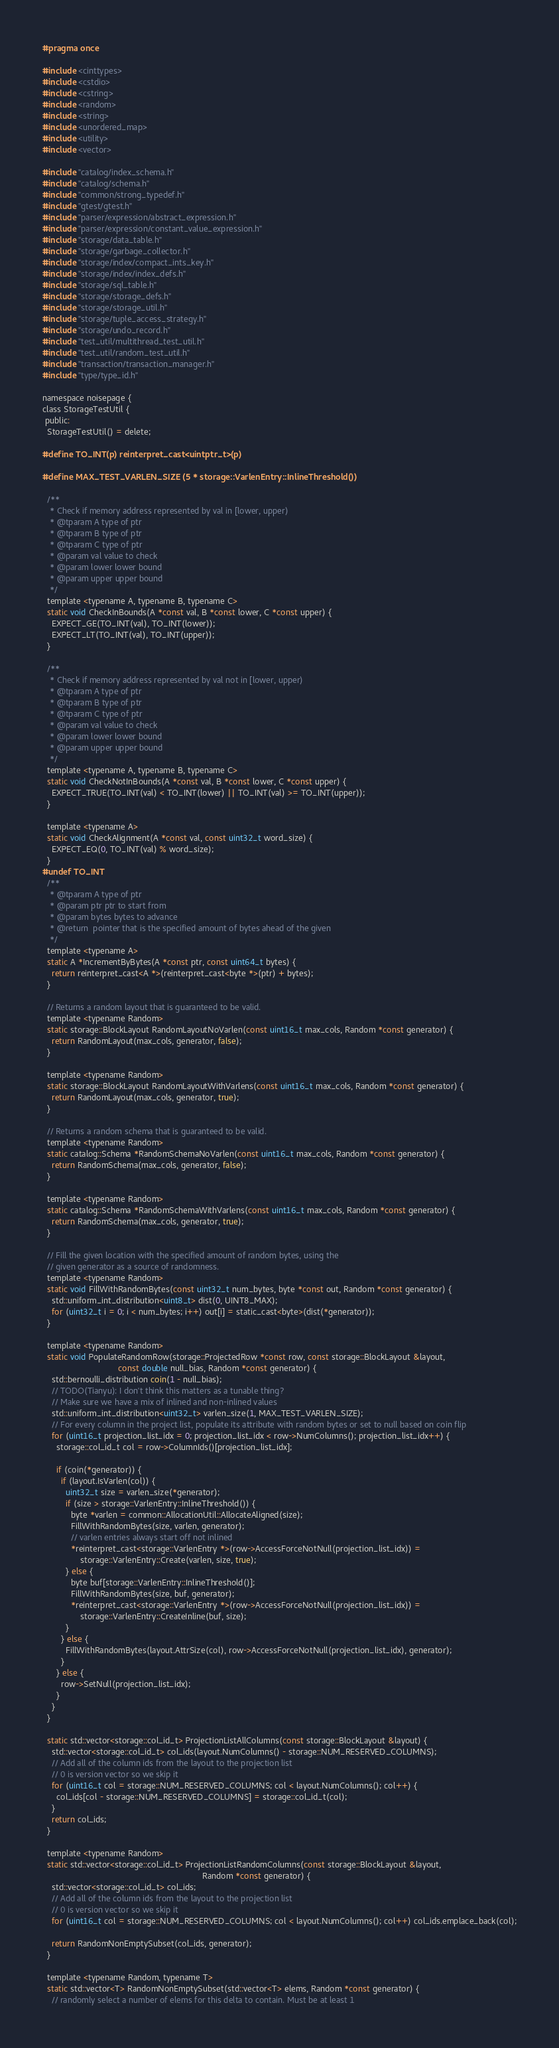<code> <loc_0><loc_0><loc_500><loc_500><_C_>#pragma once

#include <cinttypes>
#include <cstdio>
#include <cstring>
#include <random>
#include <string>
#include <unordered_map>
#include <utility>
#include <vector>

#include "catalog/index_schema.h"
#include "catalog/schema.h"
#include "common/strong_typedef.h"
#include "gtest/gtest.h"
#include "parser/expression/abstract_expression.h"
#include "parser/expression/constant_value_expression.h"
#include "storage/data_table.h"
#include "storage/garbage_collector.h"
#include "storage/index/compact_ints_key.h"
#include "storage/index/index_defs.h"
#include "storage/sql_table.h"
#include "storage/storage_defs.h"
#include "storage/storage_util.h"
#include "storage/tuple_access_strategy.h"
#include "storage/undo_record.h"
#include "test_util/multithread_test_util.h"
#include "test_util/random_test_util.h"
#include "transaction/transaction_manager.h"
#include "type/type_id.h"

namespace noisepage {
class StorageTestUtil {
 public:
  StorageTestUtil() = delete;

#define TO_INT(p) reinterpret_cast<uintptr_t>(p)

#define MAX_TEST_VARLEN_SIZE (5 * storage::VarlenEntry::InlineThreshold())

  /**
   * Check if memory address represented by val in [lower, upper)
   * @tparam A type of ptr
   * @tparam B type of ptr
   * @tparam C type of ptr
   * @param val value to check
   * @param lower lower bound
   * @param upper upper bound
   */
  template <typename A, typename B, typename C>
  static void CheckInBounds(A *const val, B *const lower, C *const upper) {
    EXPECT_GE(TO_INT(val), TO_INT(lower));
    EXPECT_LT(TO_INT(val), TO_INT(upper));
  }

  /**
   * Check if memory address represented by val not in [lower, upper)
   * @tparam A type of ptr
   * @tparam B type of ptr
   * @tparam C type of ptr
   * @param val value to check
   * @param lower lower bound
   * @param upper upper bound
   */
  template <typename A, typename B, typename C>
  static void CheckNotInBounds(A *const val, B *const lower, C *const upper) {
    EXPECT_TRUE(TO_INT(val) < TO_INT(lower) || TO_INT(val) >= TO_INT(upper));
  }

  template <typename A>
  static void CheckAlignment(A *const val, const uint32_t word_size) {
    EXPECT_EQ(0, TO_INT(val) % word_size);
  }
#undef TO_INT
  /**
   * @tparam A type of ptr
   * @param ptr ptr to start from
   * @param bytes bytes to advance
   * @return  pointer that is the specified amount of bytes ahead of the given
   */
  template <typename A>
  static A *IncrementByBytes(A *const ptr, const uint64_t bytes) {
    return reinterpret_cast<A *>(reinterpret_cast<byte *>(ptr) + bytes);
  }

  // Returns a random layout that is guaranteed to be valid.
  template <typename Random>
  static storage::BlockLayout RandomLayoutNoVarlen(const uint16_t max_cols, Random *const generator) {
    return RandomLayout(max_cols, generator, false);
  }

  template <typename Random>
  static storage::BlockLayout RandomLayoutWithVarlens(const uint16_t max_cols, Random *const generator) {
    return RandomLayout(max_cols, generator, true);
  }

  // Returns a random schema that is guaranteed to be valid.
  template <typename Random>
  static catalog::Schema *RandomSchemaNoVarlen(const uint16_t max_cols, Random *const generator) {
    return RandomSchema(max_cols, generator, false);
  }

  template <typename Random>
  static catalog::Schema *RandomSchemaWithVarlens(const uint16_t max_cols, Random *const generator) {
    return RandomSchema(max_cols, generator, true);
  }

  // Fill the given location with the specified amount of random bytes, using the
  // given generator as a source of randomness.
  template <typename Random>
  static void FillWithRandomBytes(const uint32_t num_bytes, byte *const out, Random *const generator) {
    std::uniform_int_distribution<uint8_t> dist(0, UINT8_MAX);
    for (uint32_t i = 0; i < num_bytes; i++) out[i] = static_cast<byte>(dist(*generator));
  }

  template <typename Random>
  static void PopulateRandomRow(storage::ProjectedRow *const row, const storage::BlockLayout &layout,
                                const double null_bias, Random *const generator) {
    std::bernoulli_distribution coin(1 - null_bias);
    // TODO(Tianyu): I don't think this matters as a tunable thing?
    // Make sure we have a mix of inlined and non-inlined values
    std::uniform_int_distribution<uint32_t> varlen_size(1, MAX_TEST_VARLEN_SIZE);
    // For every column in the project list, populate its attribute with random bytes or set to null based on coin flip
    for (uint16_t projection_list_idx = 0; projection_list_idx < row->NumColumns(); projection_list_idx++) {
      storage::col_id_t col = row->ColumnIds()[projection_list_idx];

      if (coin(*generator)) {
        if (layout.IsVarlen(col)) {
          uint32_t size = varlen_size(*generator);
          if (size > storage::VarlenEntry::InlineThreshold()) {
            byte *varlen = common::AllocationUtil::AllocateAligned(size);
            FillWithRandomBytes(size, varlen, generator);
            // varlen entries always start off not inlined
            *reinterpret_cast<storage::VarlenEntry *>(row->AccessForceNotNull(projection_list_idx)) =
                storage::VarlenEntry::Create(varlen, size, true);
          } else {
            byte buf[storage::VarlenEntry::InlineThreshold()];
            FillWithRandomBytes(size, buf, generator);
            *reinterpret_cast<storage::VarlenEntry *>(row->AccessForceNotNull(projection_list_idx)) =
                storage::VarlenEntry::CreateInline(buf, size);
          }
        } else {
          FillWithRandomBytes(layout.AttrSize(col), row->AccessForceNotNull(projection_list_idx), generator);
        }
      } else {
        row->SetNull(projection_list_idx);
      }
    }
  }

  static std::vector<storage::col_id_t> ProjectionListAllColumns(const storage::BlockLayout &layout) {
    std::vector<storage::col_id_t> col_ids(layout.NumColumns() - storage::NUM_RESERVED_COLUMNS);
    // Add all of the column ids from the layout to the projection list
    // 0 is version vector so we skip it
    for (uint16_t col = storage::NUM_RESERVED_COLUMNS; col < layout.NumColumns(); col++) {
      col_ids[col - storage::NUM_RESERVED_COLUMNS] = storage::col_id_t(col);
    }
    return col_ids;
  }

  template <typename Random>
  static std::vector<storage::col_id_t> ProjectionListRandomColumns(const storage::BlockLayout &layout,
                                                                    Random *const generator) {
    std::vector<storage::col_id_t> col_ids;
    // Add all of the column ids from the layout to the projection list
    // 0 is version vector so we skip it
    for (uint16_t col = storage::NUM_RESERVED_COLUMNS; col < layout.NumColumns(); col++) col_ids.emplace_back(col);

    return RandomNonEmptySubset(col_ids, generator);
  }

  template <typename Random, typename T>
  static std::vector<T> RandomNonEmptySubset(std::vector<T> elems, Random *const generator) {
    // randomly select a number of elems for this delta to contain. Must be at least 1</code> 